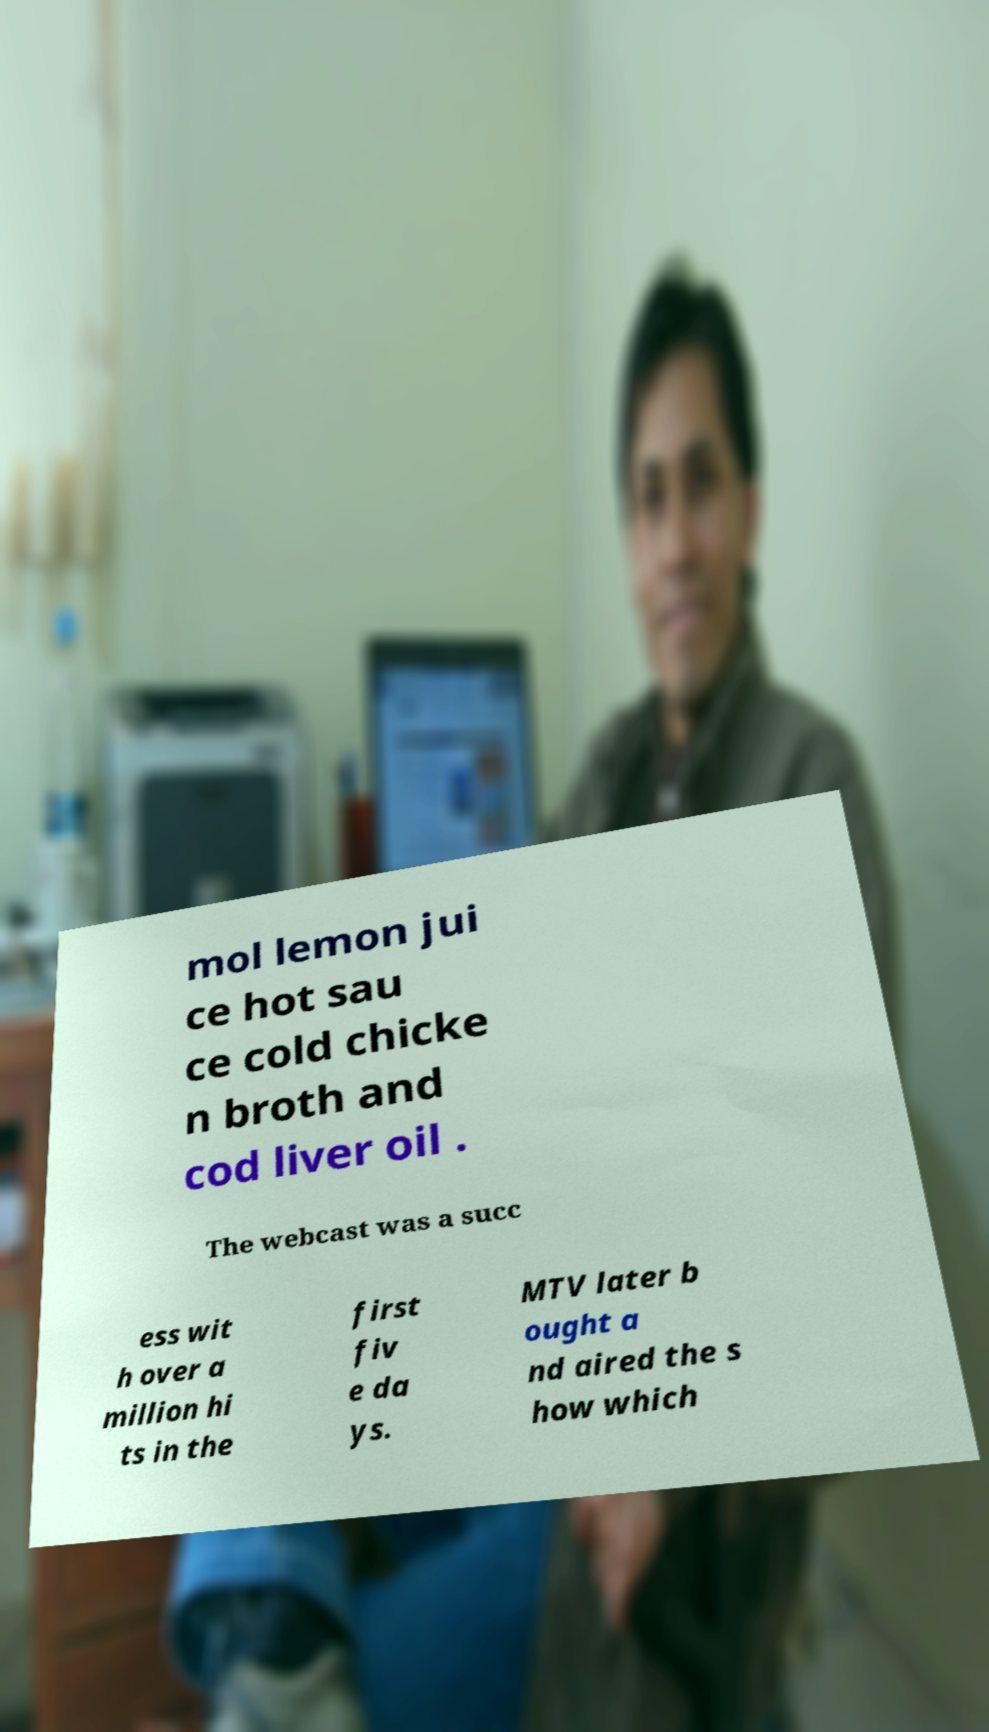Could you assist in decoding the text presented in this image and type it out clearly? mol lemon jui ce hot sau ce cold chicke n broth and cod liver oil . The webcast was a succ ess wit h over a million hi ts in the first fiv e da ys. MTV later b ought a nd aired the s how which 